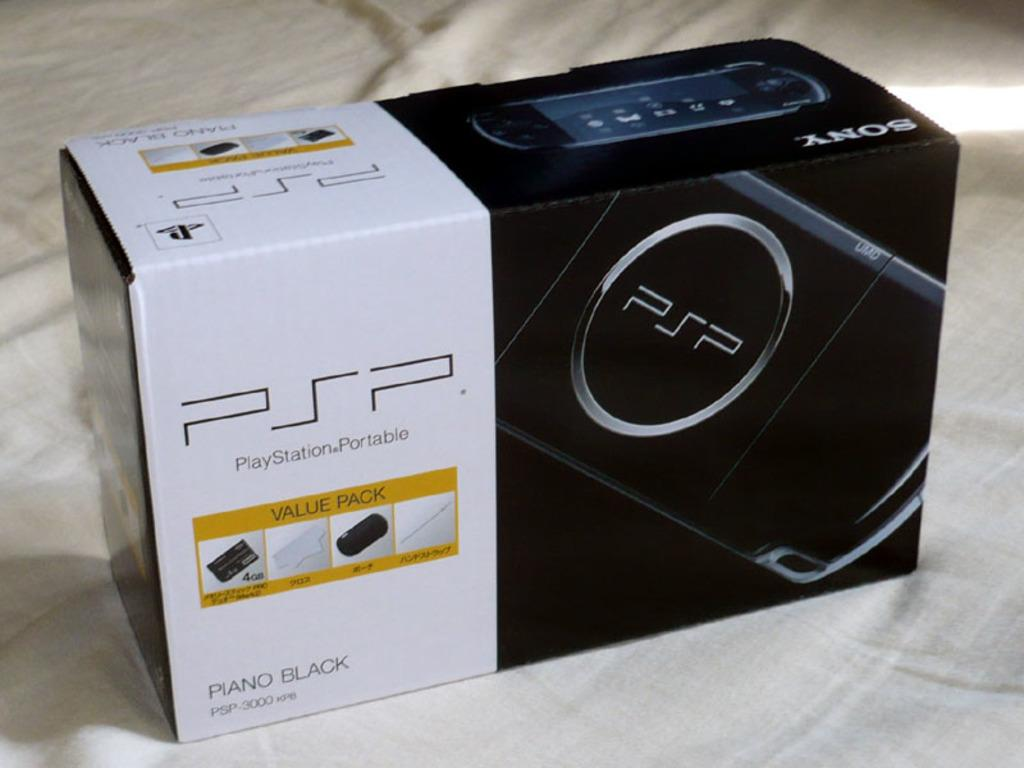<image>
Provide a brief description of the given image. a box that days Sony PSP PlayStationPortable, the item is in Piano Black. 